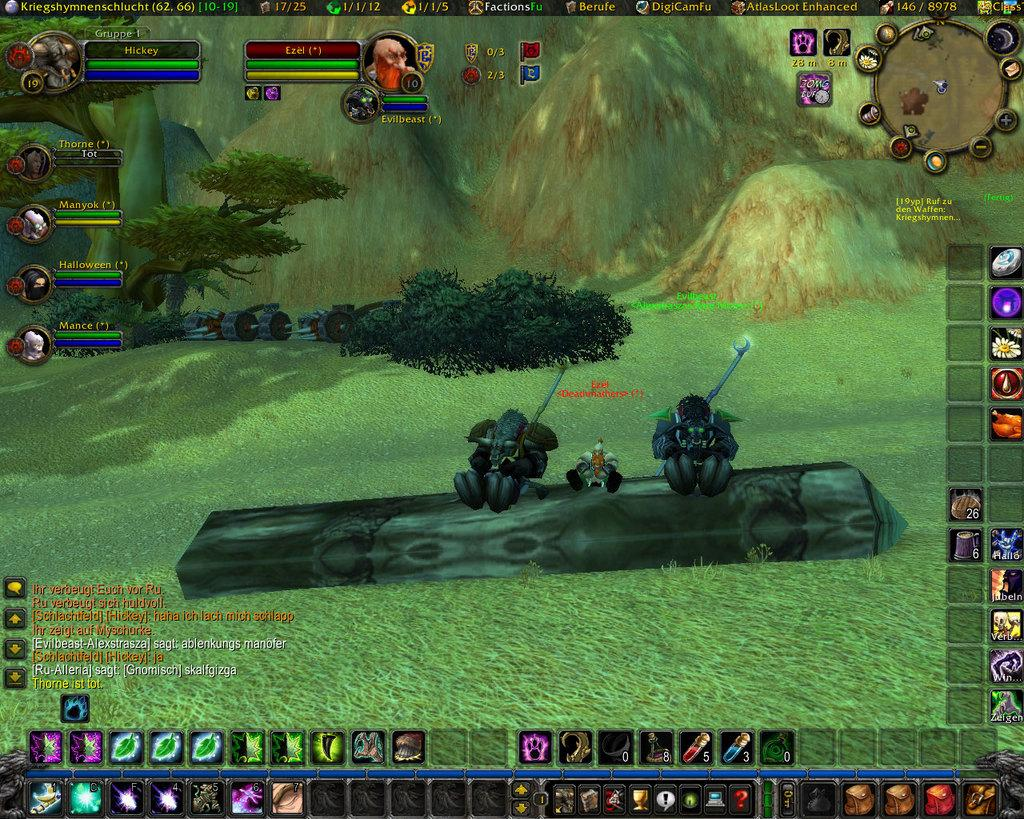What type of image is being described? The image is animated. What can be seen in the image besides the animated elements? There are many icons, trees, and hills in the image. Is there any text present in the image? Yes, there is text on the image. How many cattle can be seen grazing on the hills in the image? There are no cattle present in the image; it features animated icons, trees, and hills, along with text. What type of worm can be seen crawling on the text in the image? There are no worms present in the image; it is an animated image with icons, trees, hills, and text. 